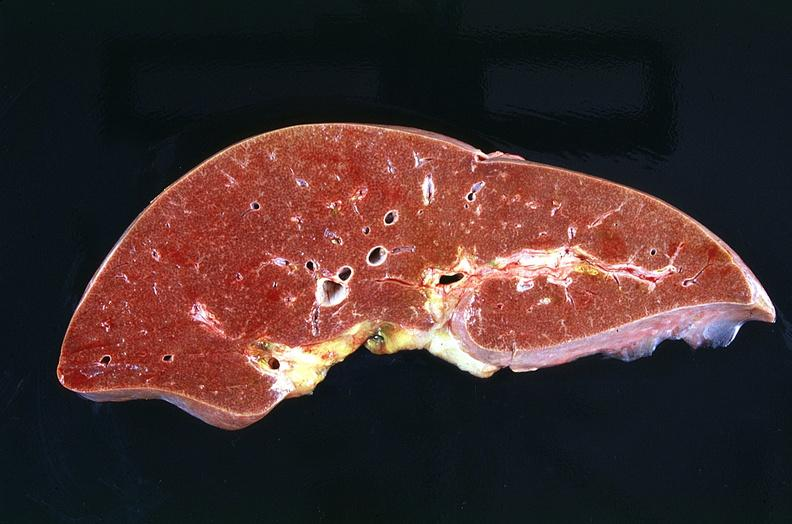what is present?
Answer the question using a single word or phrase. Hepatobiliary 